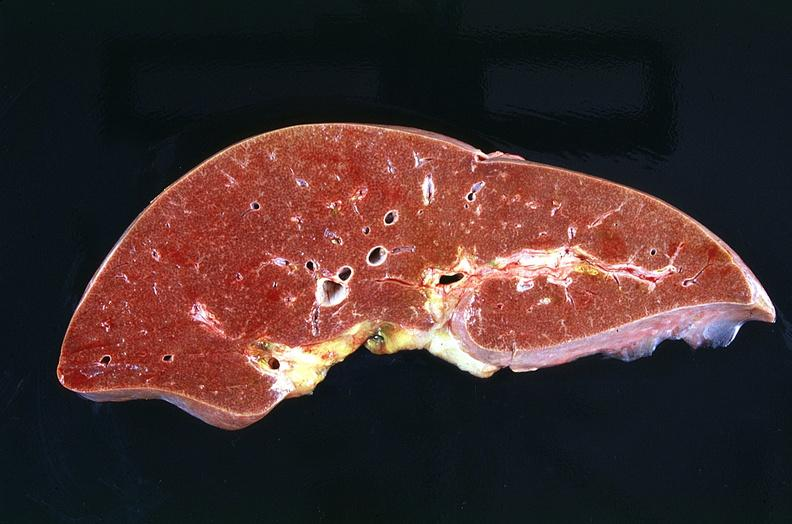what is present?
Answer the question using a single word or phrase. Hepatobiliary 